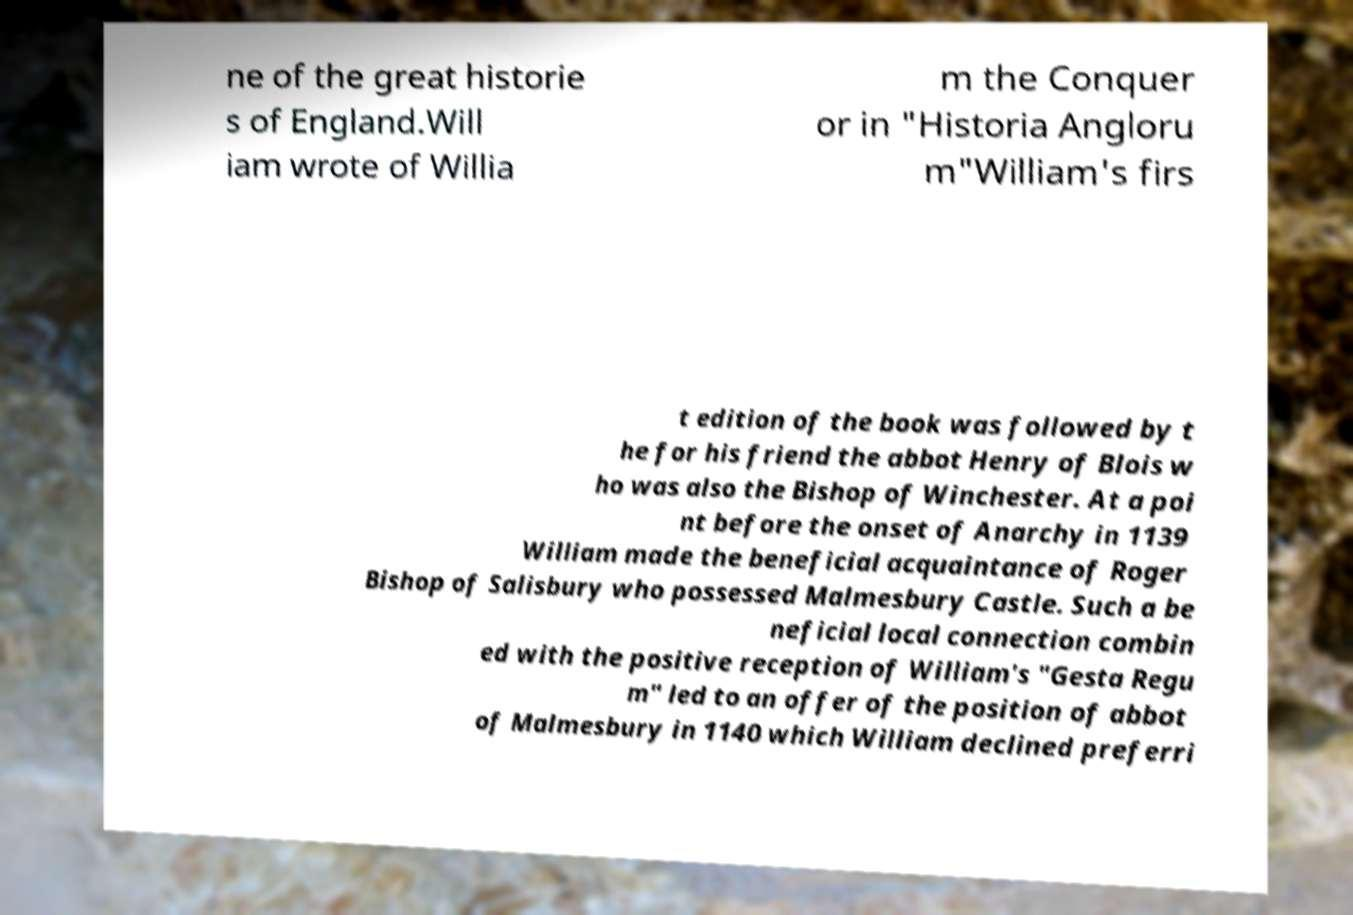Can you accurately transcribe the text from the provided image for me? ne of the great historie s of England.Will iam wrote of Willia m the Conquer or in "Historia Angloru m"William's firs t edition of the book was followed by t he for his friend the abbot Henry of Blois w ho was also the Bishop of Winchester. At a poi nt before the onset of Anarchy in 1139 William made the beneficial acquaintance of Roger Bishop of Salisbury who possessed Malmesbury Castle. Such a be neficial local connection combin ed with the positive reception of William's "Gesta Regu m" led to an offer of the position of abbot of Malmesbury in 1140 which William declined preferri 